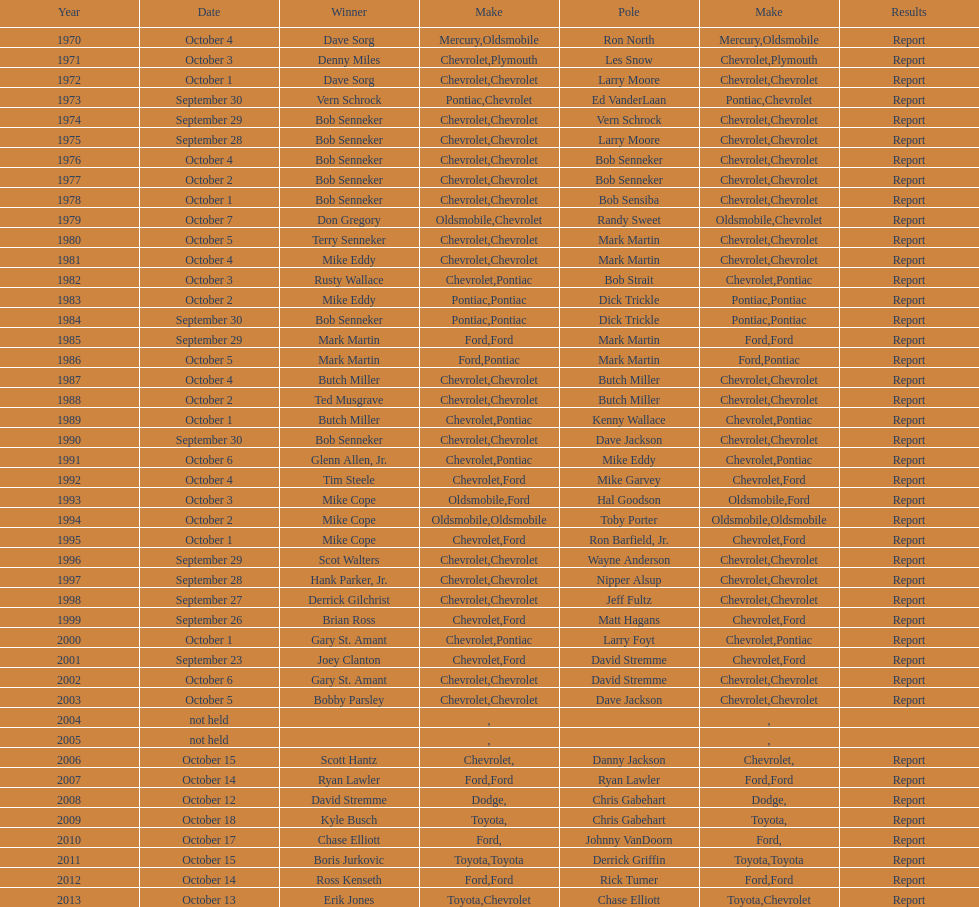What make of car had the fewest victories in races? Toyota. 